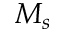<formula> <loc_0><loc_0><loc_500><loc_500>M _ { s }</formula> 